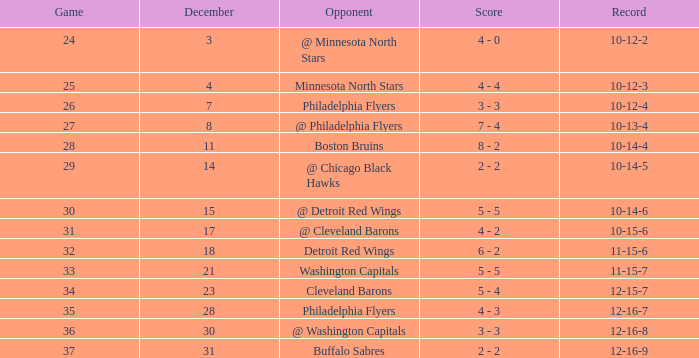What is Record, when Game is "24"? 10-12-2. 